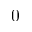<formula> <loc_0><loc_0><loc_500><loc_500>0</formula> 